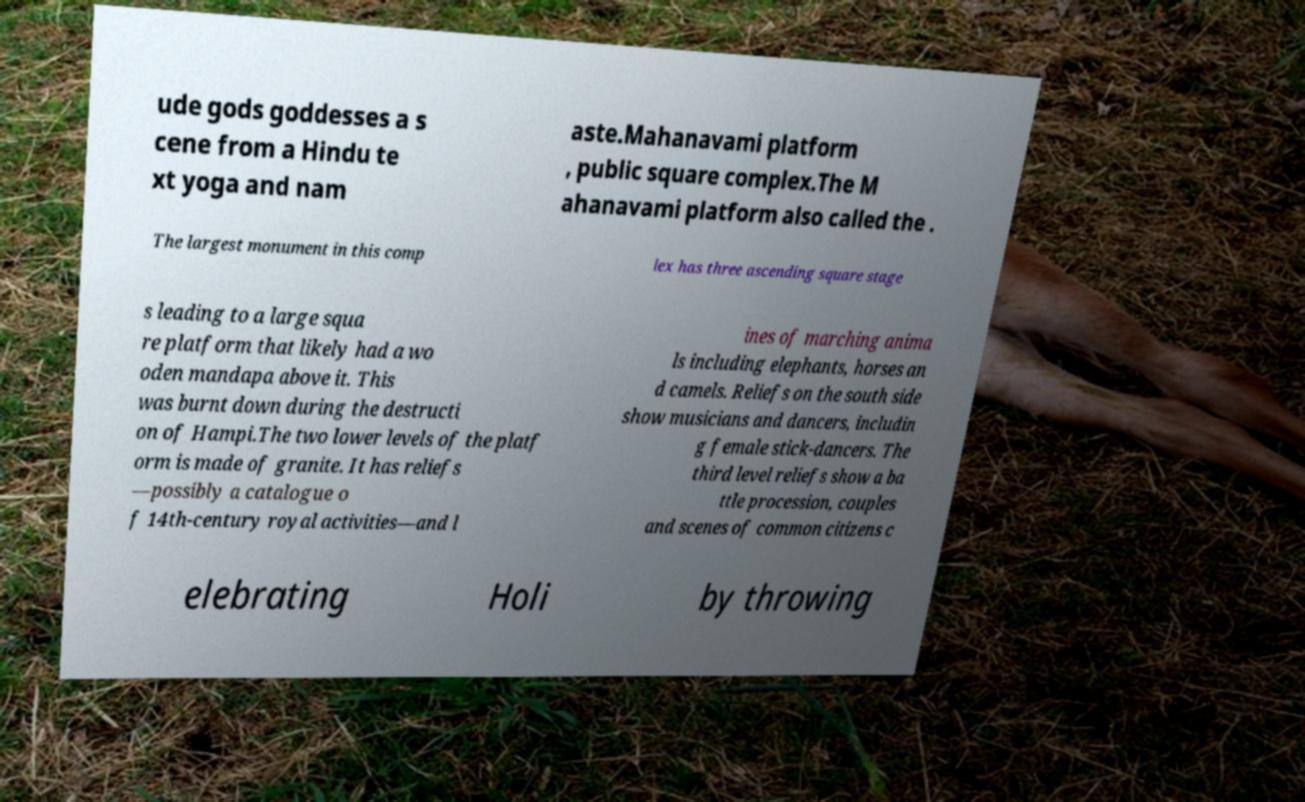There's text embedded in this image that I need extracted. Can you transcribe it verbatim? ude gods goddesses a s cene from a Hindu te xt yoga and nam aste.Mahanavami platform , public square complex.The M ahanavami platform also called the . The largest monument in this comp lex has three ascending square stage s leading to a large squa re platform that likely had a wo oden mandapa above it. This was burnt down during the destructi on of Hampi.The two lower levels of the platf orm is made of granite. It has reliefs —possibly a catalogue o f 14th-century royal activities—and l ines of marching anima ls including elephants, horses an d camels. Reliefs on the south side show musicians and dancers, includin g female stick-dancers. The third level reliefs show a ba ttle procession, couples and scenes of common citizens c elebrating Holi by throwing 